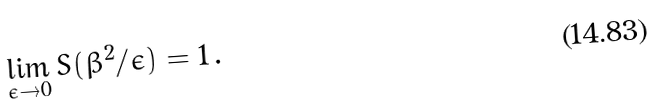<formula> <loc_0><loc_0><loc_500><loc_500>\lim _ { \epsilon \rightarrow 0 } S ( \beta ^ { 2 } / \epsilon ) = 1 \, .</formula> 